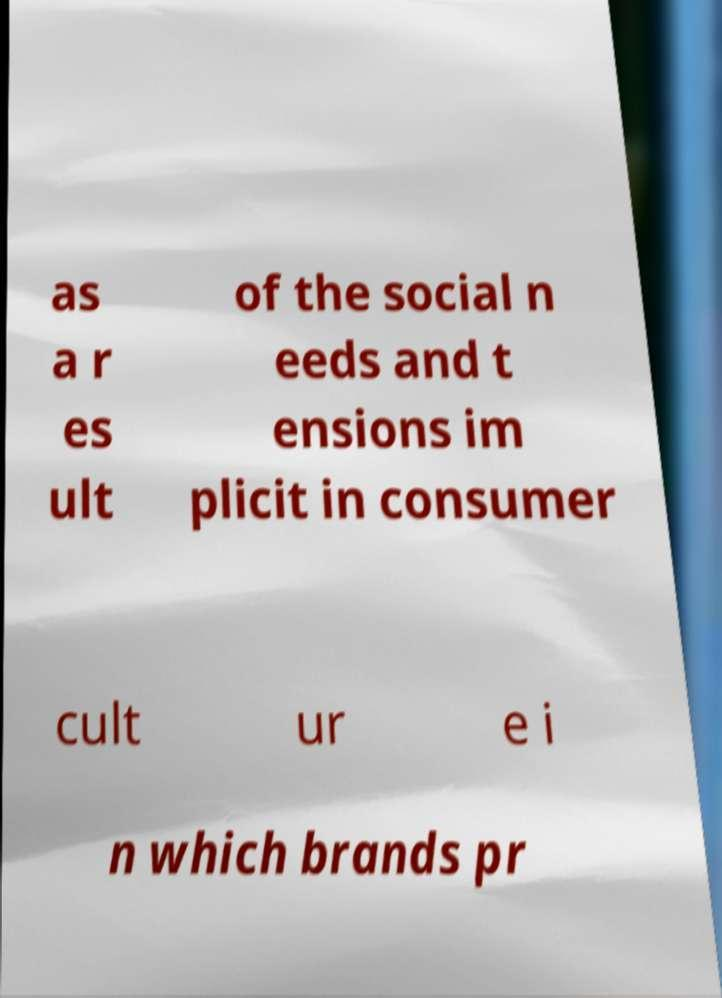Can you read and provide the text displayed in the image?This photo seems to have some interesting text. Can you extract and type it out for me? as a r es ult of the social n eeds and t ensions im plicit in consumer cult ur e i n which brands pr 